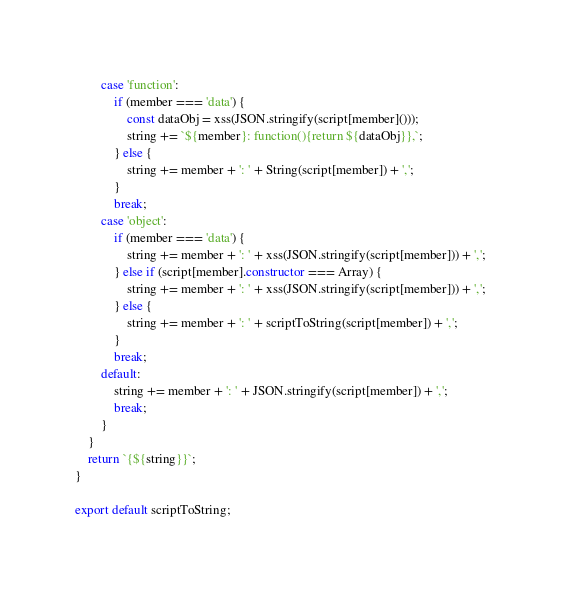Convert code to text. <code><loc_0><loc_0><loc_500><loc_500><_JavaScript_>        case 'function':
            if (member === 'data') {
                const dataObj = xss(JSON.stringify(script[member]()));
                string += `${member}: function(){return ${dataObj}},`;
            } else {
                string += member + ': ' + String(script[member]) + ',';
            }
            break;
        case 'object':
            if (member === 'data') {
                string += member + ': ' + xss(JSON.stringify(script[member])) + ',';
            } else if (script[member].constructor === Array) {
                string += member + ': ' + xss(JSON.stringify(script[member])) + ',';
            } else {
                string += member + ': ' + scriptToString(script[member]) + ',';
            }
            break;
        default:
            string += member + ': ' + JSON.stringify(script[member]) + ',';
            break;
        }
    }
    return `{${string}}`;
}

export default scriptToString;
</code> 